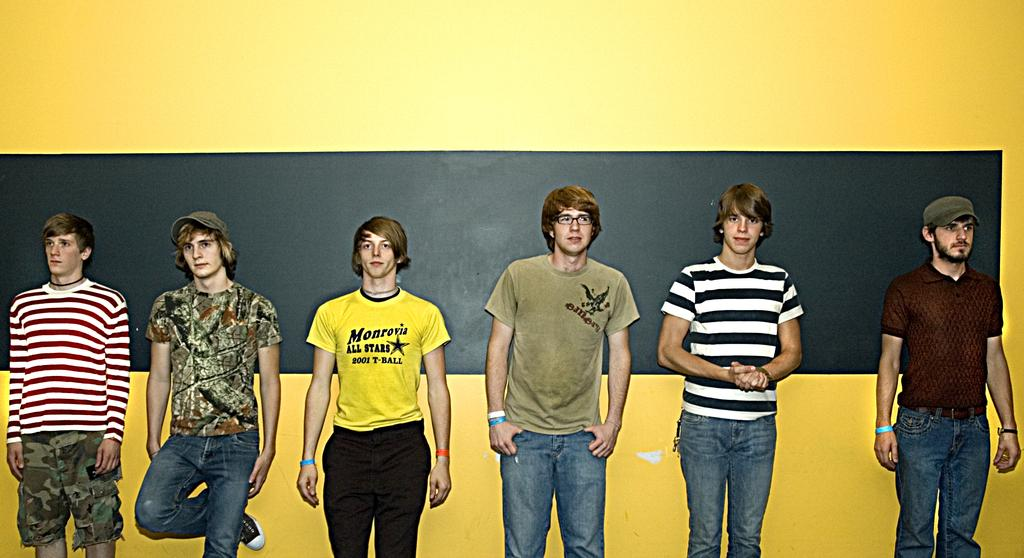How many people are in the image? There are persons in the image, but the exact number is not specified. What can be seen in the background of the image? There is a board and a yellow color wall in the background of the image. What type of tin is being used by the governor in the image? There is no tin or governor present in the image. What type of polish is being applied to the yellow wall in the image? The conversation does not mention any polish being applied to the yellow wall in the image. Reasoning: We have followed the guidelines by creating questions based on the provided facts and avoiding any reference to the absurd topics. The absurd question/answer is included to meet the requirement of having one "absurd" question per set of facts. 